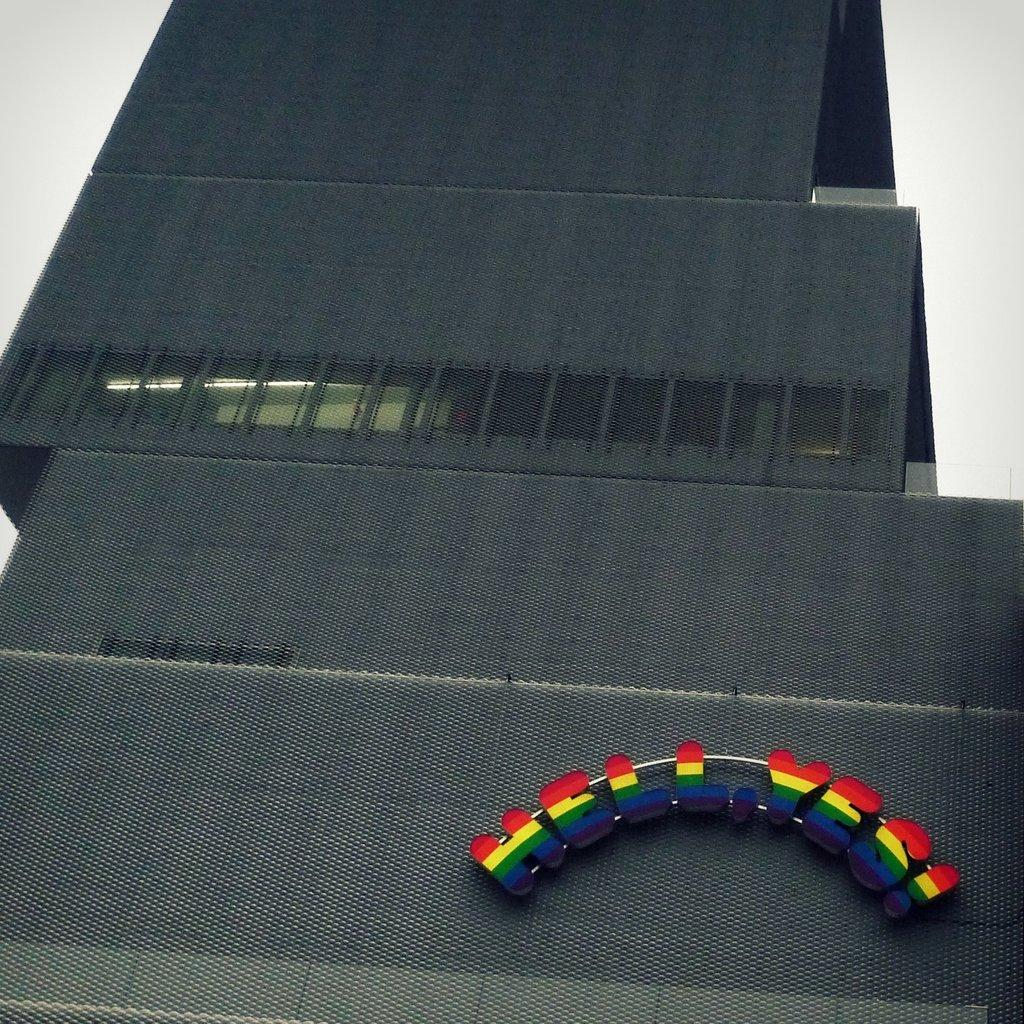What can be seen in the image? There is an object in the image. Can you describe the text on the object? The object contains 3D text. What is the manager's tendency when it comes to using yarn in the image? There is no manager or yarn present in the image, so this question cannot be answered. 